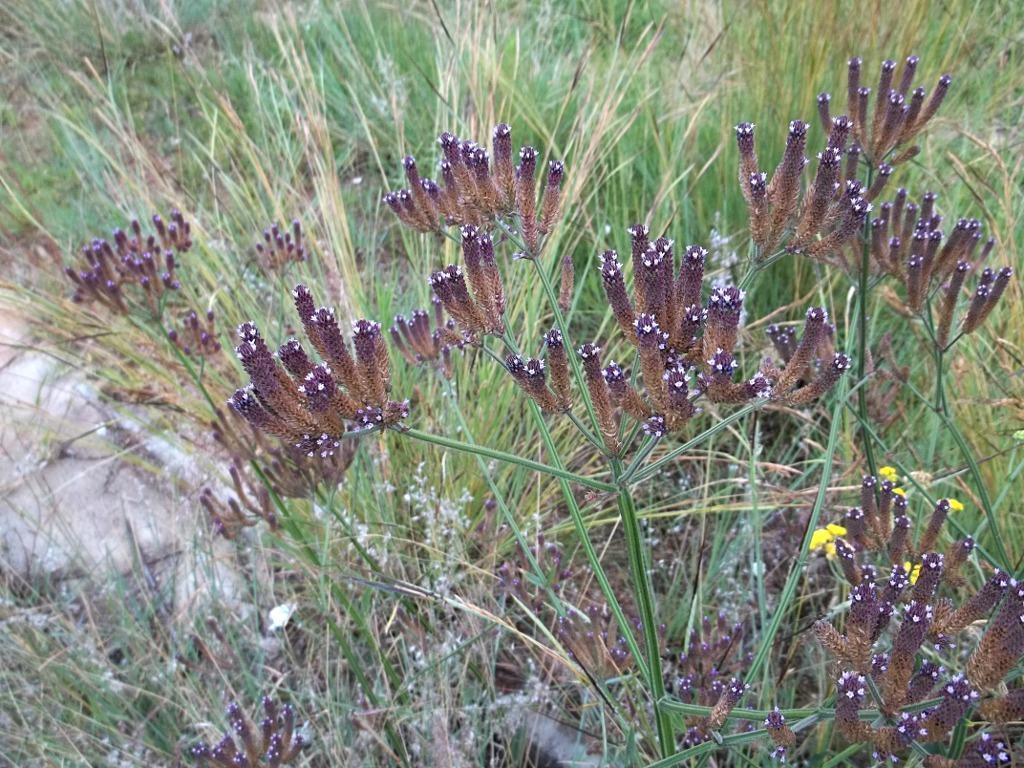Could you give a brief overview of what you see in this image? In this image I can see the grass and few flowers which are pink, brown, white and yellow in color. To the left side of the image I can see a white colored object. 